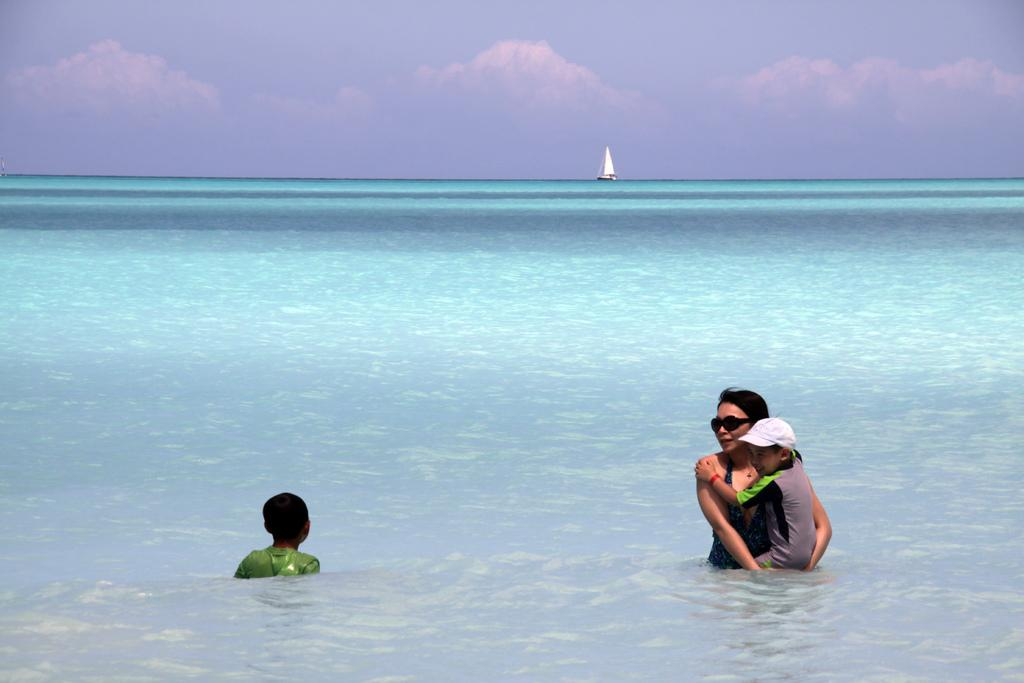What is the main subject of the image? The main subject of the image is a boat. What is the condition of the sky in the image? The sky is cloudy in the image. What type of environment is visible in the image? There is water visible in the image, suggesting a water-based environment. Can you describe the people in the image? Yes, there are people in the image, but their specific actions or characteristics are not mentioned in the provided facts. Where is the meeting taking place in the image? There is no mention of a meeting in the image or the provided facts, so it cannot be determined from the image. 